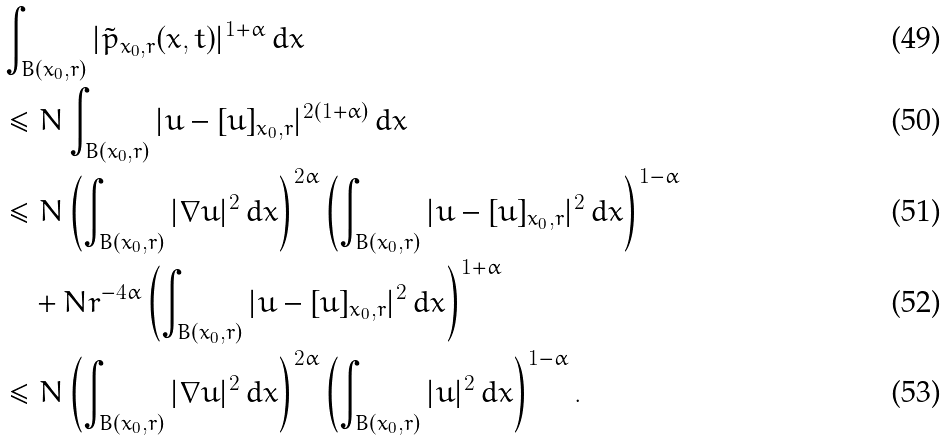Convert formula to latex. <formula><loc_0><loc_0><loc_500><loc_500>& \int _ { B ( x _ { 0 } , r ) } | { \tilde { p } } _ { x _ { 0 } , r } ( x , t ) | ^ { 1 + \alpha } \, d x \\ & \leq N \int _ { B ( x _ { 0 } , r ) } | u - [ u ] _ { x _ { 0 } , r } | ^ { 2 ( 1 + \alpha ) } \, d x \\ & \leq N \left ( \int _ { B ( x _ { 0 } , r ) } | \nabla u | ^ { 2 } \, d x \right ) ^ { 2 \alpha } \left ( \int _ { B ( x _ { 0 } , r ) } | u - [ u ] _ { x _ { 0 } , r } | ^ { 2 } \, d x \right ) ^ { 1 - \alpha } \\ & \quad + N r ^ { - 4 \alpha } \left ( \int _ { B ( x _ { 0 } , r ) } | u - [ u ] _ { x _ { 0 } , r } | ^ { 2 } \, d x \right ) ^ { 1 + \alpha } \\ & \leq N \left ( \int _ { B ( x _ { 0 } , r ) } | \nabla u | ^ { 2 } \, d x \right ) ^ { 2 \alpha } \left ( \int _ { B ( x _ { 0 } , r ) } | u | ^ { 2 } \, d x \right ) ^ { 1 - \alpha } .</formula> 